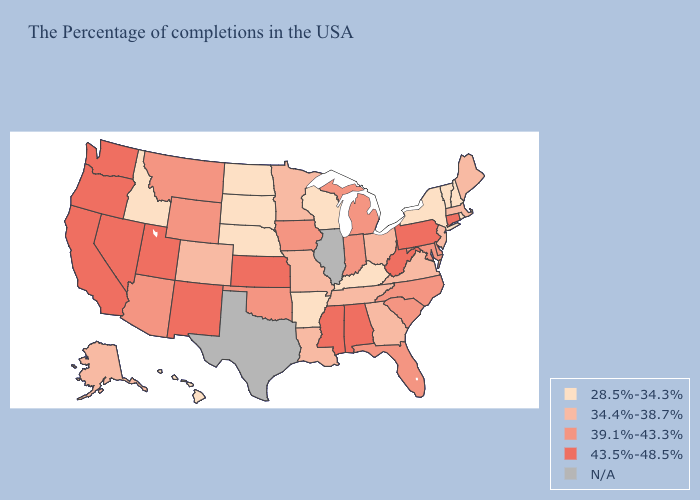What is the lowest value in the USA?
Answer briefly. 28.5%-34.3%. What is the value of Colorado?
Quick response, please. 34.4%-38.7%. Does Wyoming have the lowest value in the West?
Give a very brief answer. No. Name the states that have a value in the range 28.5%-34.3%?
Give a very brief answer. Rhode Island, New Hampshire, Vermont, New York, Kentucky, Wisconsin, Arkansas, Nebraska, South Dakota, North Dakota, Idaho, Hawaii. Name the states that have a value in the range 34.4%-38.7%?
Answer briefly. Maine, Massachusetts, New Jersey, Virginia, Ohio, Georgia, Tennessee, Louisiana, Missouri, Minnesota, Colorado, Alaska. What is the value of New Hampshire?
Write a very short answer. 28.5%-34.3%. Name the states that have a value in the range 39.1%-43.3%?
Answer briefly. Delaware, Maryland, North Carolina, South Carolina, Florida, Michigan, Indiana, Iowa, Oklahoma, Wyoming, Montana, Arizona. Name the states that have a value in the range N/A?
Write a very short answer. Illinois, Texas. Which states hav the highest value in the South?
Quick response, please. West Virginia, Alabama, Mississippi. Among the states that border Montana , which have the lowest value?
Give a very brief answer. South Dakota, North Dakota, Idaho. Which states have the highest value in the USA?
Be succinct. Connecticut, Pennsylvania, West Virginia, Alabama, Mississippi, Kansas, New Mexico, Utah, Nevada, California, Washington, Oregon. Does New York have the lowest value in the USA?
Short answer required. Yes. Name the states that have a value in the range 34.4%-38.7%?
Answer briefly. Maine, Massachusetts, New Jersey, Virginia, Ohio, Georgia, Tennessee, Louisiana, Missouri, Minnesota, Colorado, Alaska. What is the value of Connecticut?
Give a very brief answer. 43.5%-48.5%. 